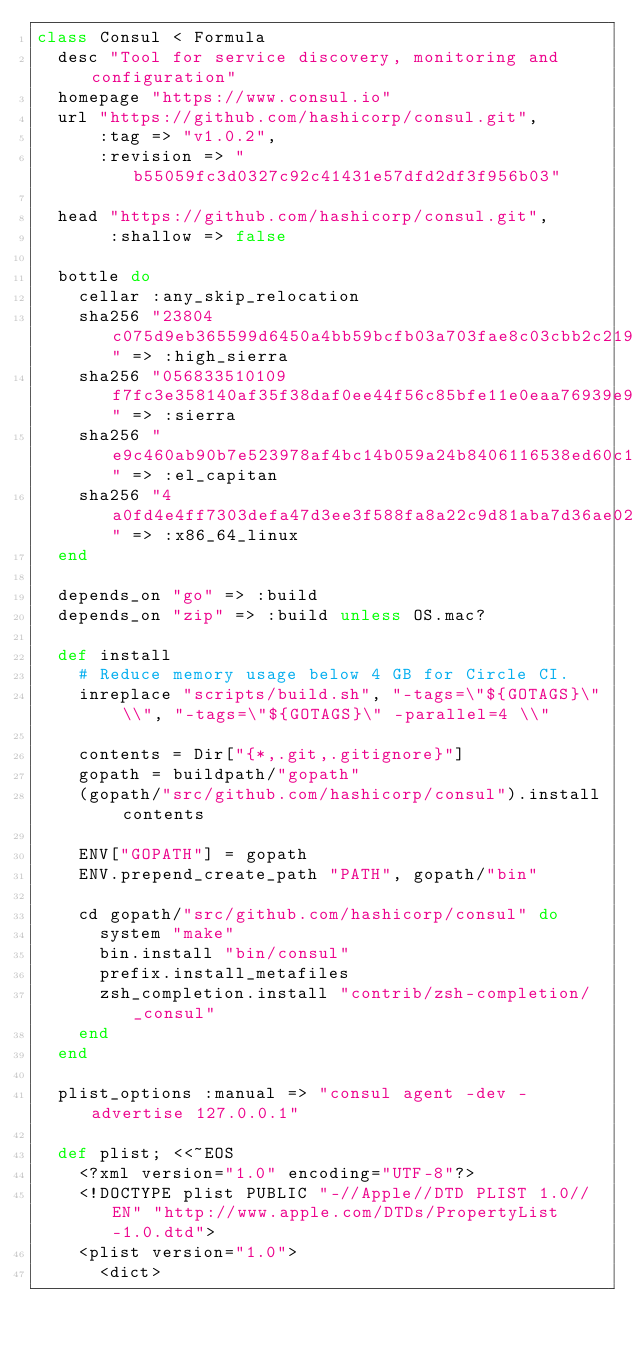Convert code to text. <code><loc_0><loc_0><loc_500><loc_500><_Ruby_>class Consul < Formula
  desc "Tool for service discovery, monitoring and configuration"
  homepage "https://www.consul.io"
  url "https://github.com/hashicorp/consul.git",
      :tag => "v1.0.2",
      :revision => "b55059fc3d0327c92c41431e57dfd2df3f956b03"

  head "https://github.com/hashicorp/consul.git",
       :shallow => false

  bottle do
    cellar :any_skip_relocation
    sha256 "23804c075d9eb365599d6450a4bb59bcfb03a703fae8c03cbb2c2196156474e2" => :high_sierra
    sha256 "056833510109f7fc3e358140af35f38daf0ee44f56c85bfe11e0eaa76939e9e4" => :sierra
    sha256 "e9c460ab90b7e523978af4bc14b059a24b8406116538ed60c10a616c4c18dee2" => :el_capitan
    sha256 "4a0fd4e4ff7303defa47d3ee3f588fa8a22c9d81aba7d36ae02f293cd29ef790" => :x86_64_linux
  end

  depends_on "go" => :build
  depends_on "zip" => :build unless OS.mac?

  def install
    # Reduce memory usage below 4 GB for Circle CI.
    inreplace "scripts/build.sh", "-tags=\"${GOTAGS}\" \\", "-tags=\"${GOTAGS}\" -parallel=4 \\"

    contents = Dir["{*,.git,.gitignore}"]
    gopath = buildpath/"gopath"
    (gopath/"src/github.com/hashicorp/consul").install contents

    ENV["GOPATH"] = gopath
    ENV.prepend_create_path "PATH", gopath/"bin"

    cd gopath/"src/github.com/hashicorp/consul" do
      system "make"
      bin.install "bin/consul"
      prefix.install_metafiles
      zsh_completion.install "contrib/zsh-completion/_consul"
    end
  end

  plist_options :manual => "consul agent -dev -advertise 127.0.0.1"

  def plist; <<~EOS
    <?xml version="1.0" encoding="UTF-8"?>
    <!DOCTYPE plist PUBLIC "-//Apple//DTD PLIST 1.0//EN" "http://www.apple.com/DTDs/PropertyList-1.0.dtd">
    <plist version="1.0">
      <dict></code> 